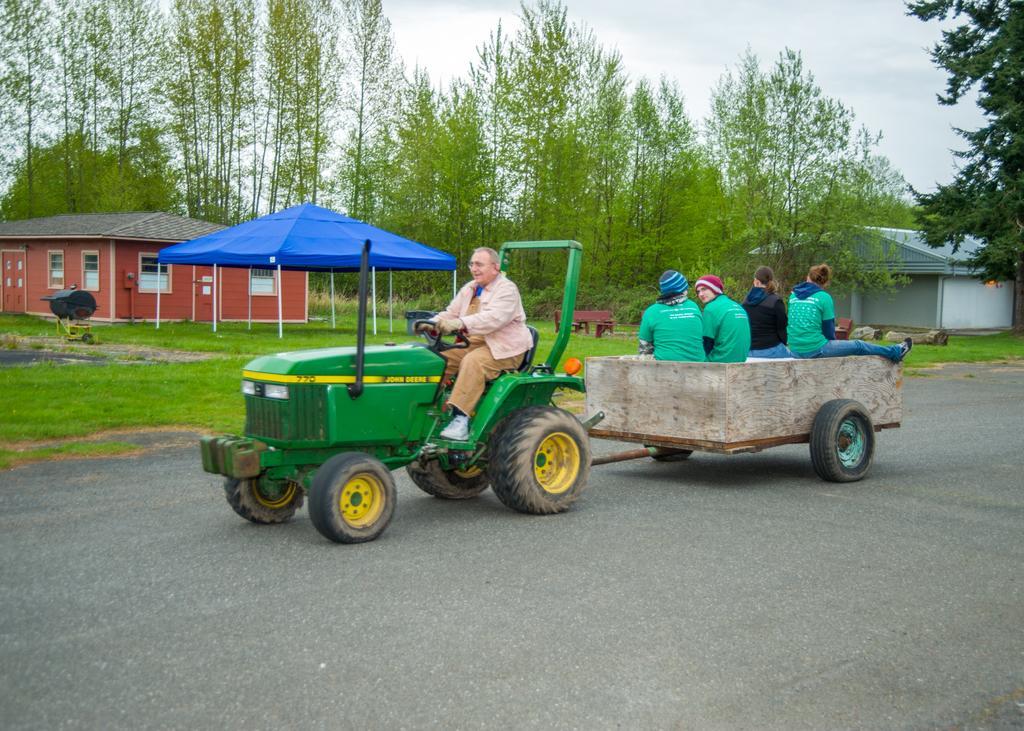Please provide a concise description of this image. In this picture I can see a man driving a tractor and few are sitting in the trolley. I can see trees, few hours, a tent and a bench on the ground. I can see tree barks, grass on the ground and a cloudy sky. 